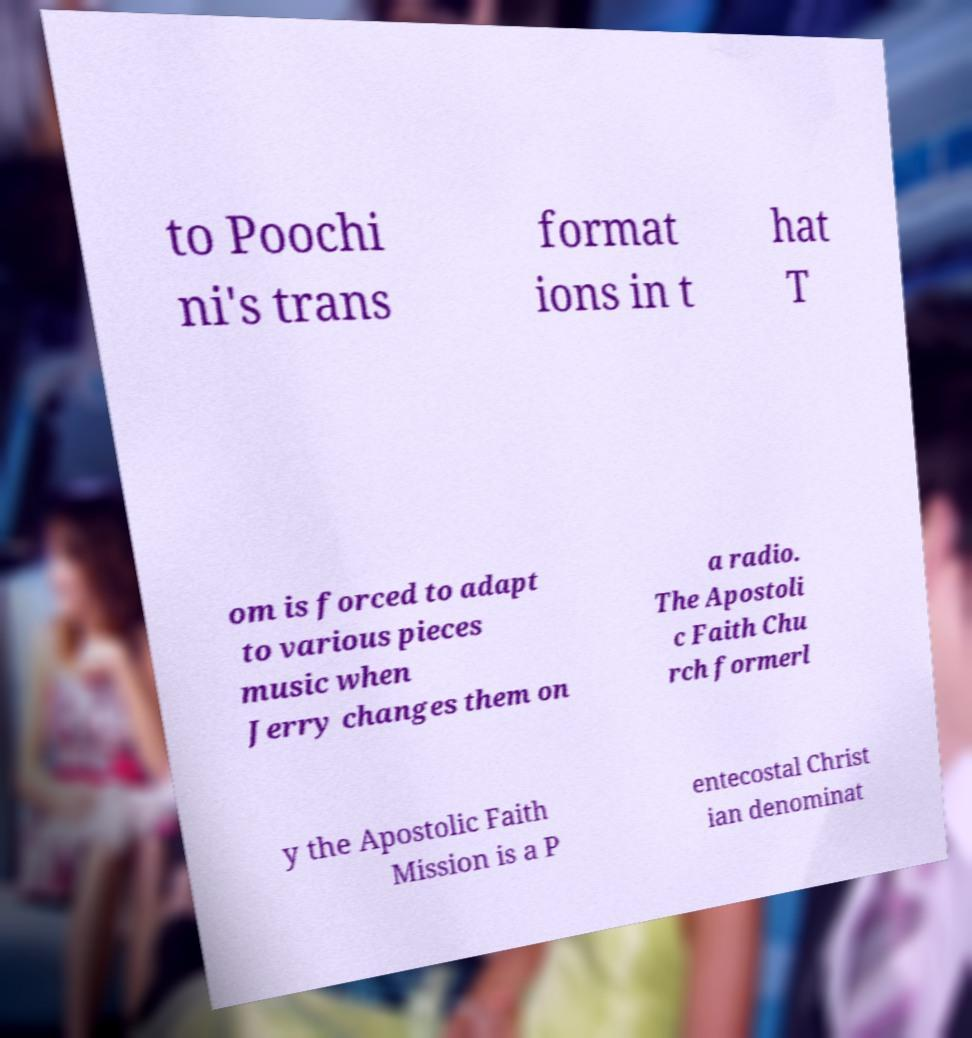I need the written content from this picture converted into text. Can you do that? to Poochi ni's trans format ions in t hat T om is forced to adapt to various pieces music when Jerry changes them on a radio. The Apostoli c Faith Chu rch formerl y the Apostolic Faith Mission is a P entecostal Christ ian denominat 